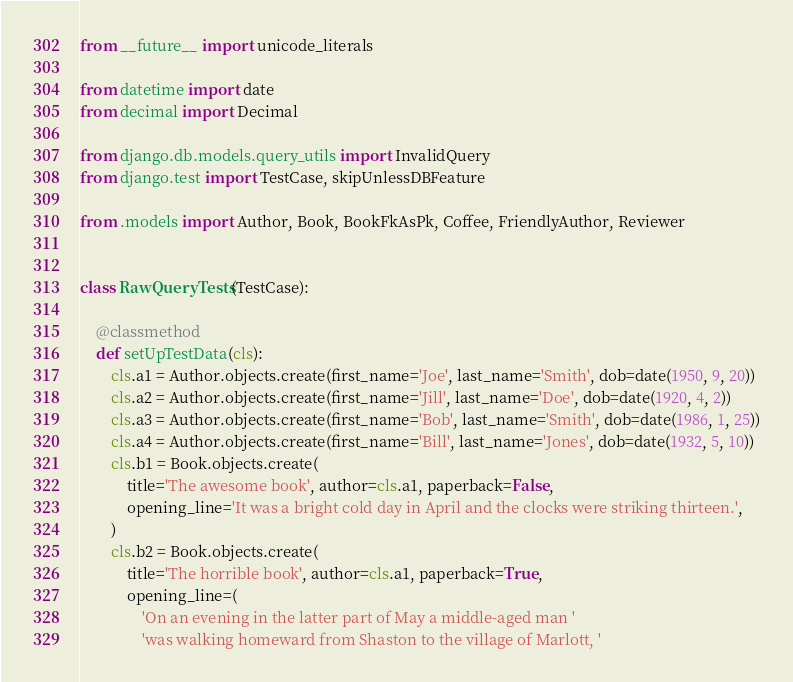<code> <loc_0><loc_0><loc_500><loc_500><_Python_>from __future__ import unicode_literals

from datetime import date
from decimal import Decimal

from django.db.models.query_utils import InvalidQuery
from django.test import TestCase, skipUnlessDBFeature

from .models import Author, Book, BookFkAsPk, Coffee, FriendlyAuthor, Reviewer


class RawQueryTests(TestCase):

    @classmethod
    def setUpTestData(cls):
        cls.a1 = Author.objects.create(first_name='Joe', last_name='Smith', dob=date(1950, 9, 20))
        cls.a2 = Author.objects.create(first_name='Jill', last_name='Doe', dob=date(1920, 4, 2))
        cls.a3 = Author.objects.create(first_name='Bob', last_name='Smith', dob=date(1986, 1, 25))
        cls.a4 = Author.objects.create(first_name='Bill', last_name='Jones', dob=date(1932, 5, 10))
        cls.b1 = Book.objects.create(
            title='The awesome book', author=cls.a1, paperback=False,
            opening_line='It was a bright cold day in April and the clocks were striking thirteen.',
        )
        cls.b2 = Book.objects.create(
            title='The horrible book', author=cls.a1, paperback=True,
            opening_line=(
                'On an evening in the latter part of May a middle-aged man '
                'was walking homeward from Shaston to the village of Marlott, '</code> 